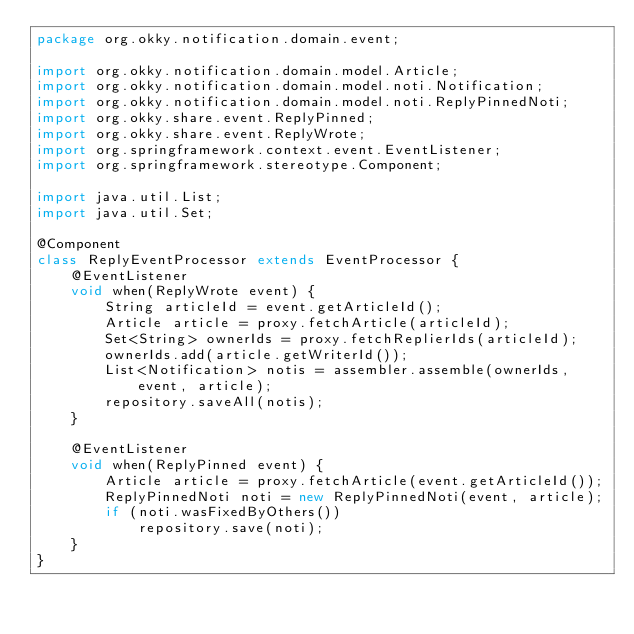<code> <loc_0><loc_0><loc_500><loc_500><_Java_>package org.okky.notification.domain.event;

import org.okky.notification.domain.model.Article;
import org.okky.notification.domain.model.noti.Notification;
import org.okky.notification.domain.model.noti.ReplyPinnedNoti;
import org.okky.share.event.ReplyPinned;
import org.okky.share.event.ReplyWrote;
import org.springframework.context.event.EventListener;
import org.springframework.stereotype.Component;

import java.util.List;
import java.util.Set;

@Component
class ReplyEventProcessor extends EventProcessor {
    @EventListener
    void when(ReplyWrote event) {
        String articleId = event.getArticleId();
        Article article = proxy.fetchArticle(articleId);
        Set<String> ownerIds = proxy.fetchReplierIds(articleId);
        ownerIds.add(article.getWriterId());
        List<Notification> notis = assembler.assemble(ownerIds, event, article);
        repository.saveAll(notis);
    }

    @EventListener
    void when(ReplyPinned event) {
        Article article = proxy.fetchArticle(event.getArticleId());
        ReplyPinnedNoti noti = new ReplyPinnedNoti(event, article);
        if (noti.wasFixedByOthers())
            repository.save(noti);
    }
}
</code> 